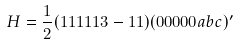Convert formula to latex. <formula><loc_0><loc_0><loc_500><loc_500>H = \frac { 1 } { 2 } ( 1 1 1 1 1 3 - 1 1 ) ( 0 0 0 0 0 a b c ) ^ { \prime }</formula> 